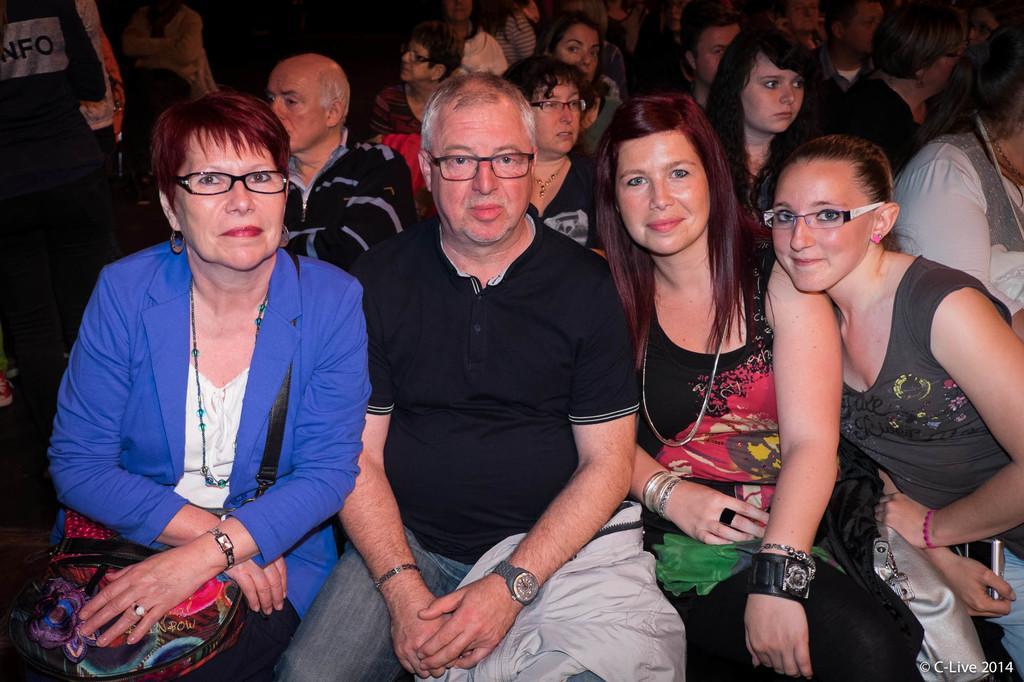How would you summarize this image in a sentence or two? In this picture, there are people sitting on the chairs. In the center, there are four people. Among them, three are women and one is man. Man is wearing a black t shirt and blue jeans. Towards the left, there is a woman wearing a blue blazer and holding a bag on her lap. Towards the right, there is a woman wearing a black top and another woman is wearing a grey top. 